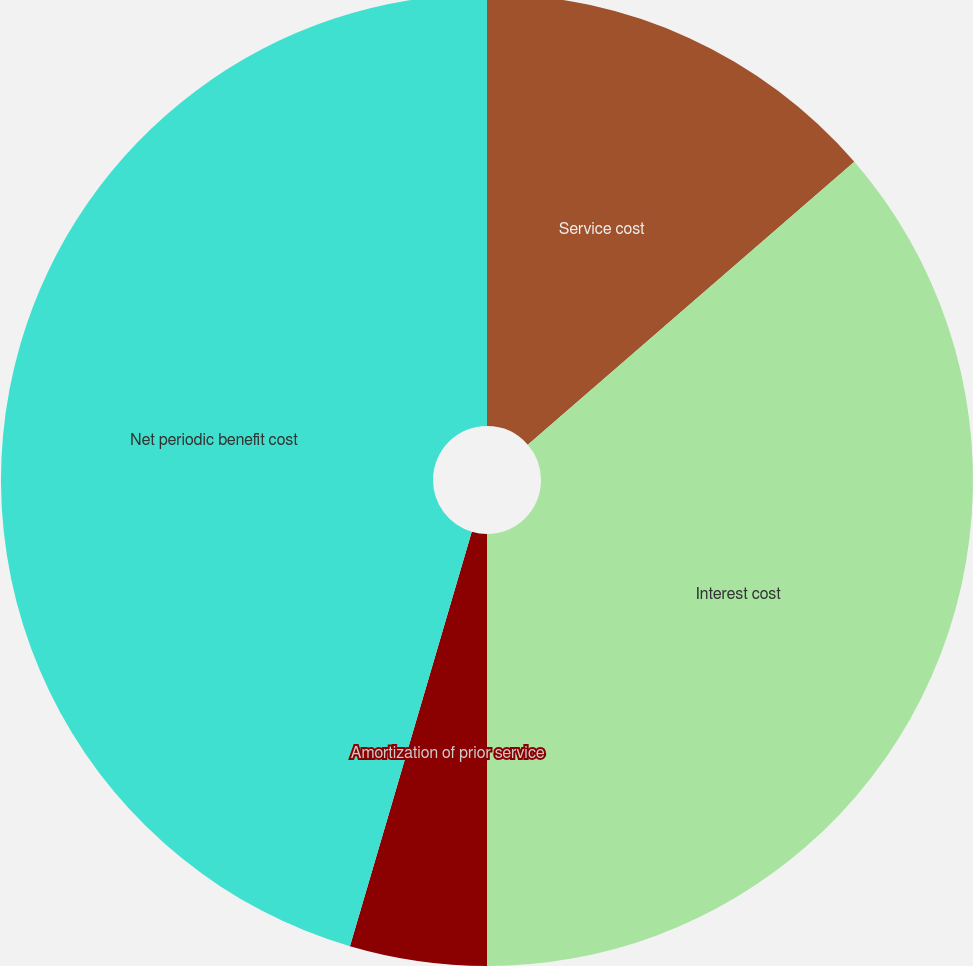Convert chart. <chart><loc_0><loc_0><loc_500><loc_500><pie_chart><fcel>Service cost<fcel>Interest cost<fcel>Amortization of prior service<fcel>Net periodic benefit cost<nl><fcel>13.64%<fcel>36.36%<fcel>4.55%<fcel>45.45%<nl></chart> 